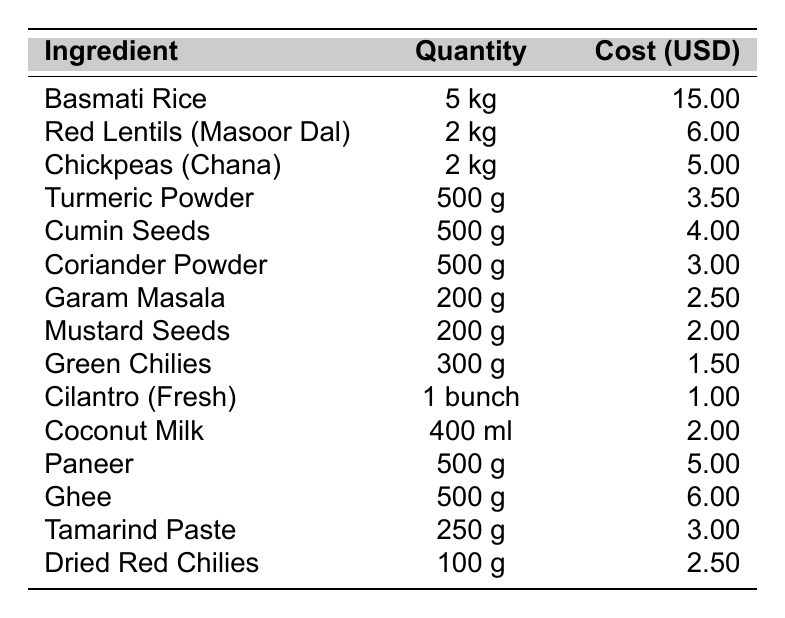What is the cost of Basmati Rice? The table shows that the cost for Basmati Rice is listed under the "Cost (USD)" column next to it. It is $15.00.
Answer: $15.00 How much is spent on Green Chilies? The cost associated with Green Chilies is directly provided in the corresponding row of the table, which is $1.50.
Answer: $1.50 Which ingredient has the highest cost? To find the highest cost, we can compare all the values in the "Cost (USD)" column. Basmati Rice has the highest cost at $15.00.
Answer: Basmati Rice What is the total cost of all the ingredients? We add up all the costs from the "Cost (USD)" column: 15 + 6 + 5 + 3.5 + 4 + 3 + 2.5 + 2 + 1.5 + 1 + 2 + 5 + 6 + 3 + 2.5 = 56.00.
Answer: $56.00 What is the average cost of the ingredients listed? First, we find the total cost, which is $56.00. There are 15 ingredients, so we divide the total cost by the number of ingredients: 56.00 / 15 = 3.73.
Answer: $3.73 Is the cost of Paneer less than that of Ghee? The cost of Paneer is $5.00, and the cost of Ghee is $6.00. Since $5.00 is less than $6.00, the statement is true.
Answer: Yes How much does Turmeric Powder cost compared to Cumin Seeds? Turmeric Powder costs $3.50 and Cumin Seeds cost $4.00. Since $3.50 is less than $4.00, we can conclude that Turmeric Powder is cheaper.
Answer: Turmeric Powder is cheaper If I buy 3 kg of Red Lentils, how much would that cost? Red Lentils (Masoor Dal) costs $6.00 for 2 kg. Therefore, the cost for 3 kg would be (3 kg / 2 kg) * $6.00 = $9.00.
Answer: $9.00 What is the cumulative cost of Lentils and Chickpeas? The cost of Red Lentils is $6.00 and Chickpeas is $5.00. We sum them up: 6.00 + 5.00 = 11.00.
Answer: $11.00 Which ingredient has a cost that is equal to or less than $3.00? We check the "Cost (USD)" column for values equal to or below $3.00. The ingredients that meet this criteria are: Garam Masala ($2.50), Mustard Seeds ($2.00), Green Chilies ($1.50), Cilantro ($1.00), Coconut Milk ($2.00), and Tamarind Paste ($3.00).
Answer: Garam Masala, Mustard Seeds, Green Chilies, Cilantro, Coconut Milk, Tamarind Paste 